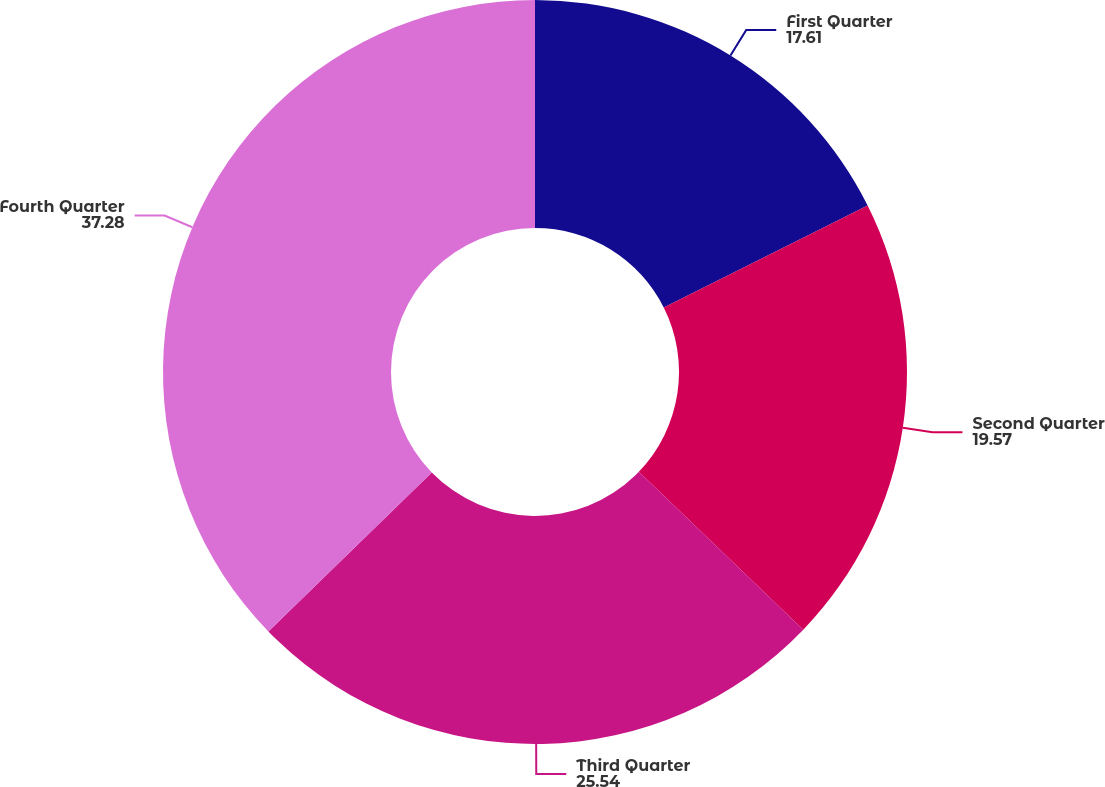Convert chart to OTSL. <chart><loc_0><loc_0><loc_500><loc_500><pie_chart><fcel>First Quarter<fcel>Second Quarter<fcel>Third Quarter<fcel>Fourth Quarter<nl><fcel>17.61%<fcel>19.57%<fcel>25.54%<fcel>37.28%<nl></chart> 